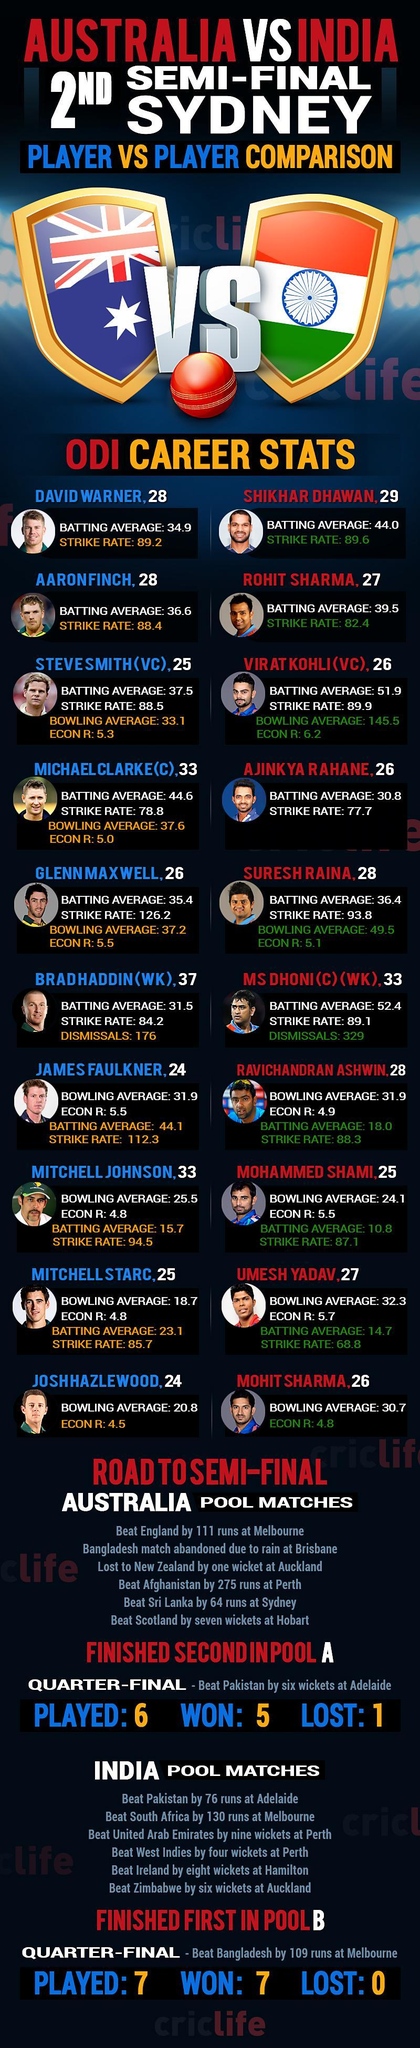Against which country Australia has the big win by wicket?
Answer the question with a short phrase. Scotland How many players with a strike rate of more than 100? 2 What is the strike rate of Umesh Yadav 68.8 What is the percentage of wins for India out of the 7 matches played 100 How many players with age 29? 1 Against which country India has the big win by run? South Africa How many players with a batting average of more than 50? 2 Who is the wicket keeper of Australia Bradhaddin Who is the wicket keeper of India MS Dhoni 